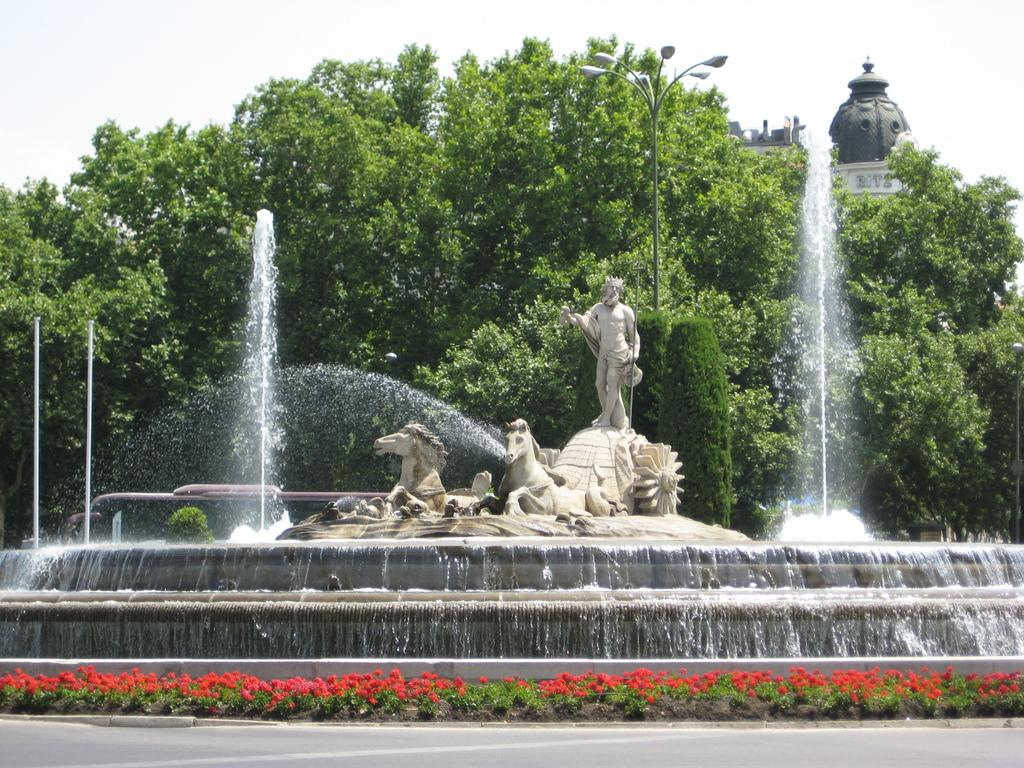What type of natural elements can be seen in the image? There are trees in the image. What type of artistic elements can be seen in the image? There are sculptures in the image. What type of water feature is visible in the image? There is water visible in the image. What part of the natural environment is visible in the image? The sky is visible in the image. Where is the clock located in the image? There is no clock present in the image. Can you see a giraffe in the image? No, there is no giraffe in the image. 